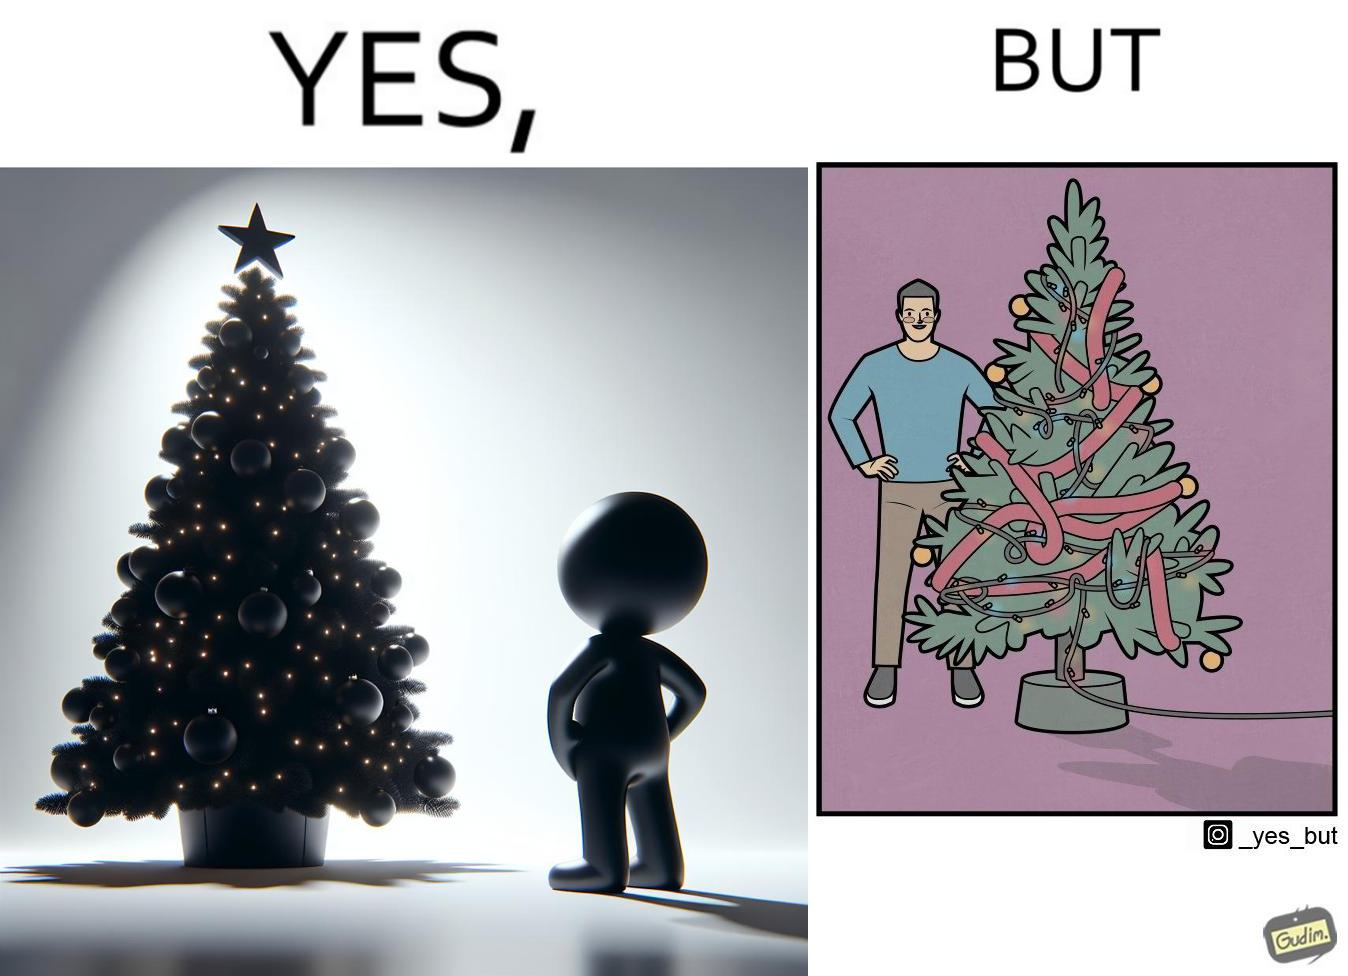What is shown in this image? The image is ironic, because in the first image a person is seen watching his decorated X-mas tree but in the second image it is shown that the tree is looking beautiful not due to its natural beauty but the bulbs connected via power decorated over it 